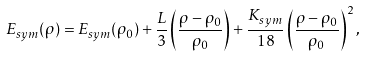Convert formula to latex. <formula><loc_0><loc_0><loc_500><loc_500>E _ { s y m } ( \rho ) = E _ { s y m } ( \rho _ { 0 } ) + \frac { L } { 3 } \left ( \frac { \rho - \rho _ { 0 } } { \rho _ { 0 } } \right ) + \frac { K _ { s y m } } { 1 8 } \left ( \frac { \rho - \rho _ { 0 } } { \rho _ { 0 } } \right ) ^ { 2 } ,</formula> 